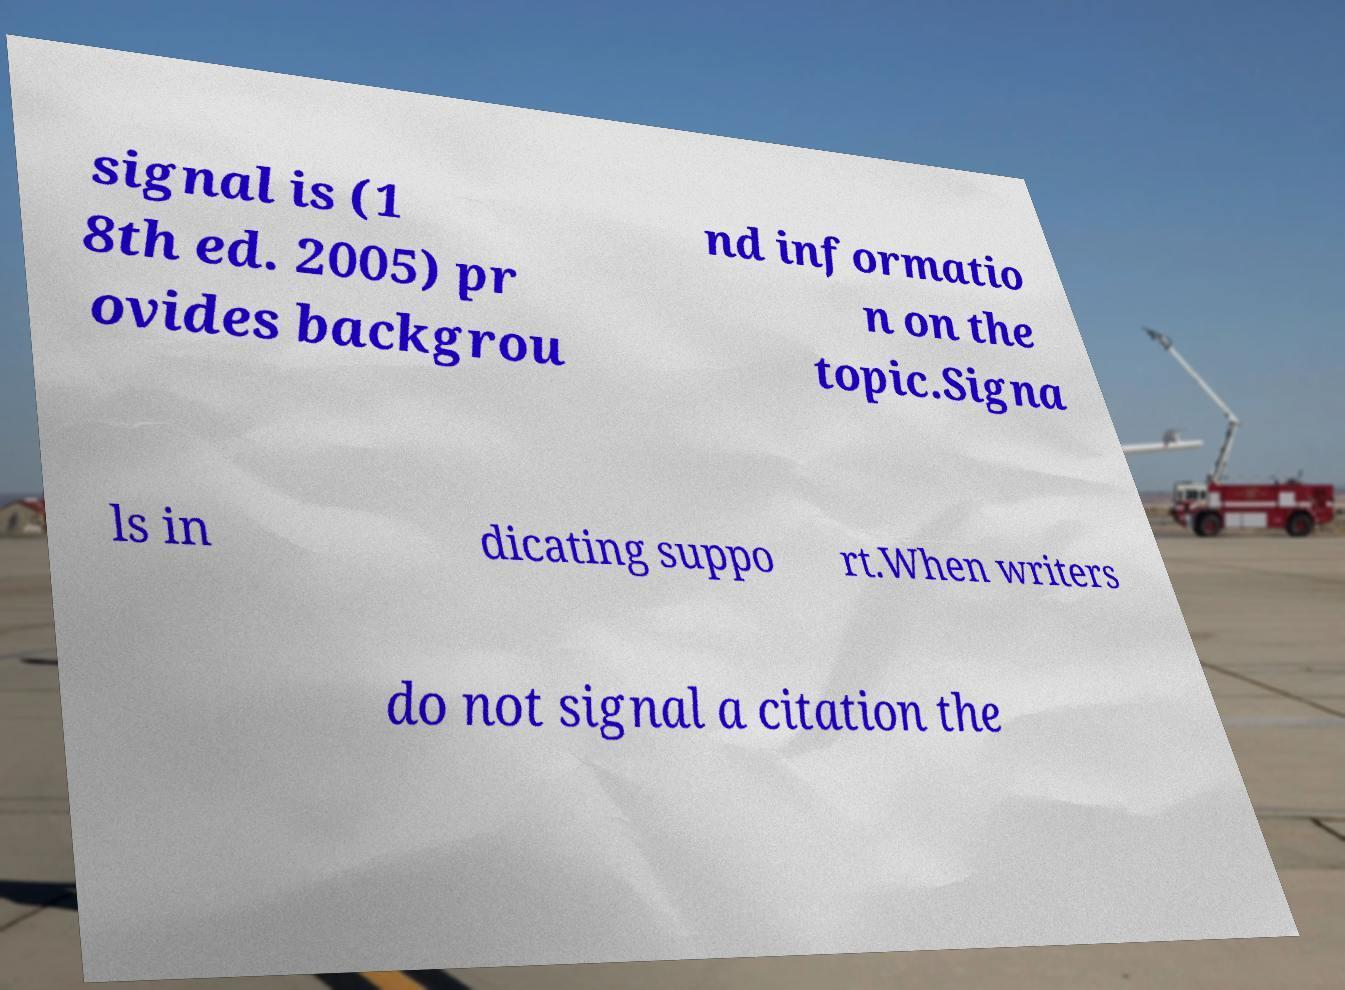Could you extract and type out the text from this image? signal is (1 8th ed. 2005) pr ovides backgrou nd informatio n on the topic.Signa ls in dicating suppo rt.When writers do not signal a citation the 